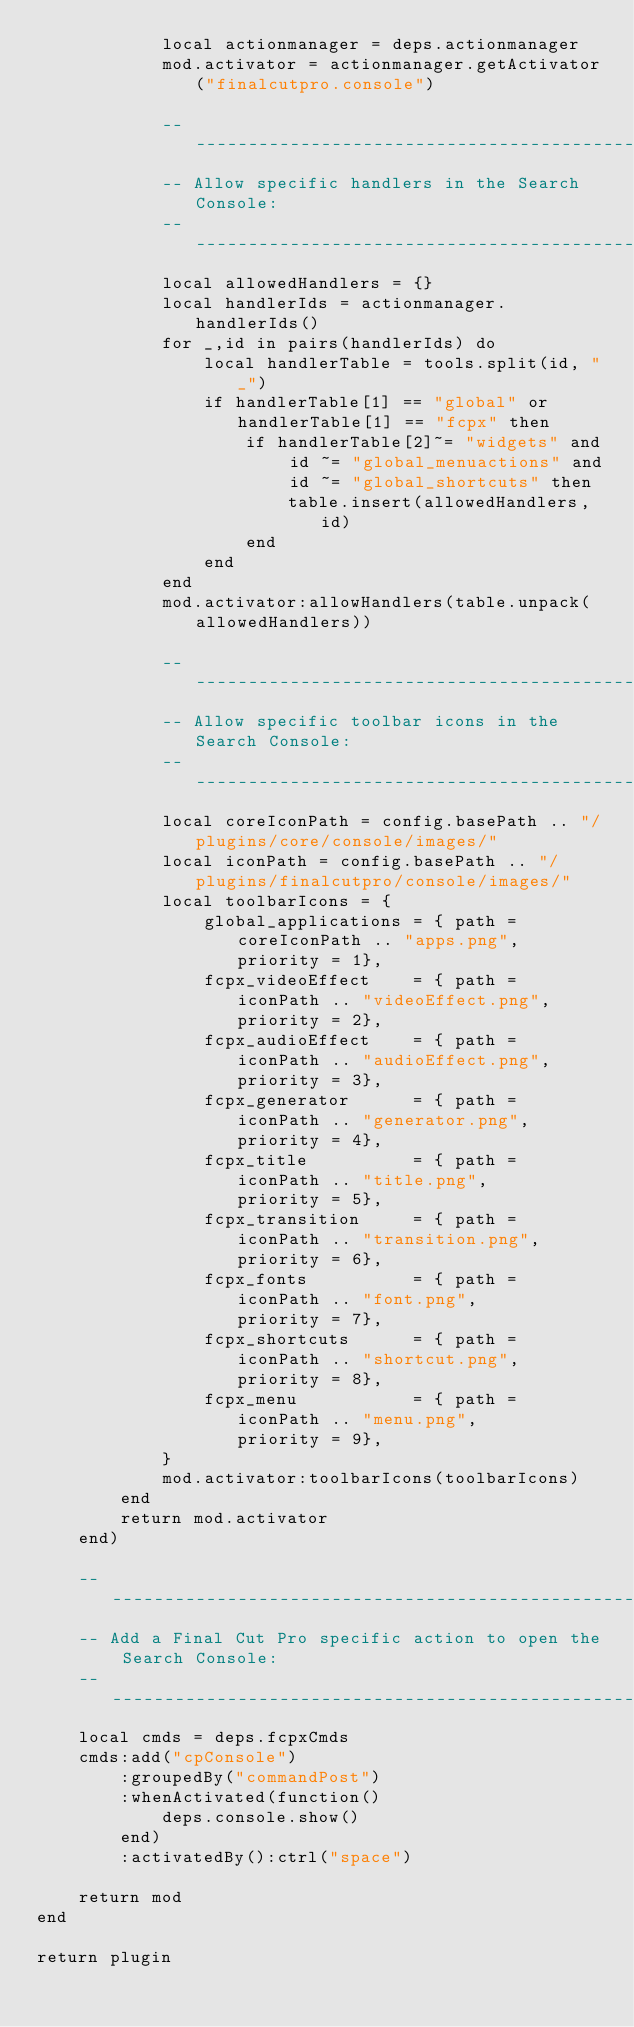<code> <loc_0><loc_0><loc_500><loc_500><_Lua_>            local actionmanager = deps.actionmanager
            mod.activator = actionmanager.getActivator("finalcutpro.console")

            --------------------------------------------------------------------------------
            -- Allow specific handlers in the Search Console:
            --------------------------------------------------------------------------------
            local allowedHandlers = {}
            local handlerIds = actionmanager.handlerIds()
            for _,id in pairs(handlerIds) do
                local handlerTable = tools.split(id, "_")
                if handlerTable[1] == "global" or handlerTable[1] == "fcpx" then
                    if handlerTable[2]~= "widgets" and id ~= "global_menuactions" and id ~= "global_shortcuts" then
                        table.insert(allowedHandlers, id)
                    end
                end
            end
            mod.activator:allowHandlers(table.unpack(allowedHandlers))

            --------------------------------------------------------------------------------
            -- Allow specific toolbar icons in the Search Console:
            --------------------------------------------------------------------------------
            local coreIconPath = config.basePath .. "/plugins/core/console/images/"
            local iconPath = config.basePath .. "/plugins/finalcutpro/console/images/"
            local toolbarIcons = {
                global_applications = { path = coreIconPath .. "apps.png",      priority = 1},
                fcpx_videoEffect    = { path = iconPath .. "videoEffect.png",   priority = 2},
                fcpx_audioEffect    = { path = iconPath .. "audioEffect.png",   priority = 3},
                fcpx_generator      = { path = iconPath .. "generator.png",     priority = 4},
                fcpx_title          = { path = iconPath .. "title.png",         priority = 5},
                fcpx_transition     = { path = iconPath .. "transition.png",    priority = 6},
                fcpx_fonts          = { path = iconPath .. "font.png",          priority = 7},
                fcpx_shortcuts      = { path = iconPath .. "shortcut.png",      priority = 8},
                fcpx_menu           = { path = iconPath .. "menu.png",          priority = 9},
            }
            mod.activator:toolbarIcons(toolbarIcons)
        end
        return mod.activator
    end)

    --------------------------------------------------------------------------------
    -- Add a Final Cut Pro specific action to open the Search Console:
    --------------------------------------------------------------------------------
    local cmds = deps.fcpxCmds
    cmds:add("cpConsole")
        :groupedBy("commandPost")
        :whenActivated(function()
            deps.console.show()
        end)
        :activatedBy():ctrl("space")

    return mod
end

return plugin
</code> 